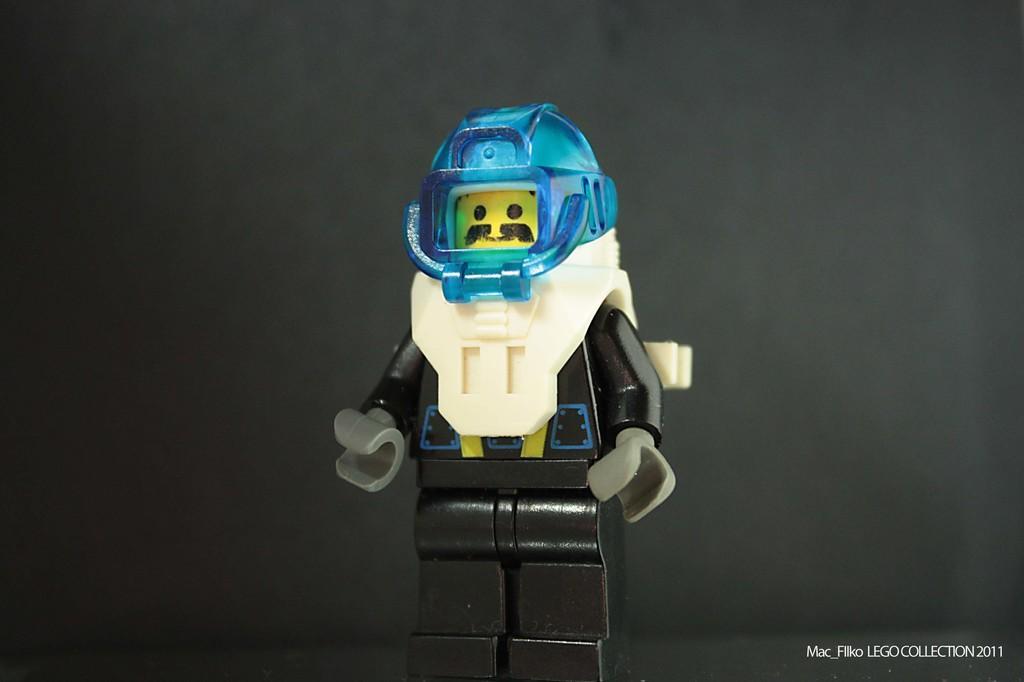How would you summarize this image in a sentence or two? This picture contains a toy robot in black color and it is having a blue helmet. In the background, it is black in color. 